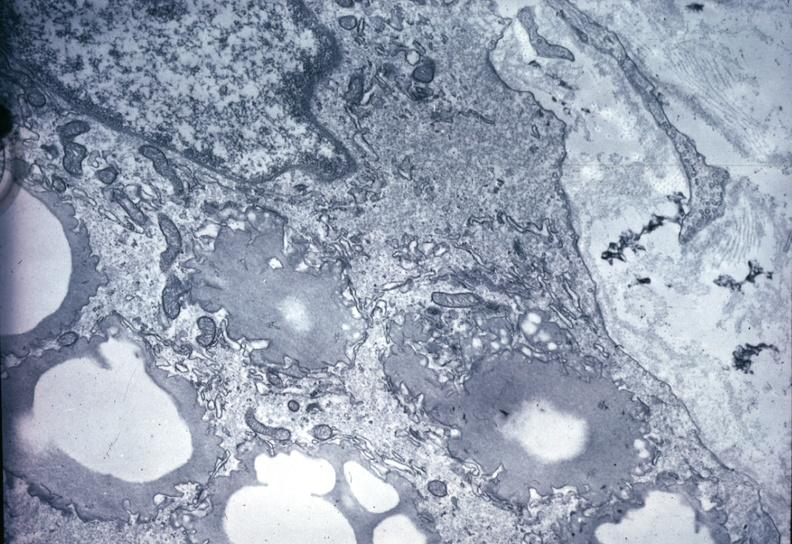where is this area in the body?
Answer the question using a single word or phrase. Vasculature 